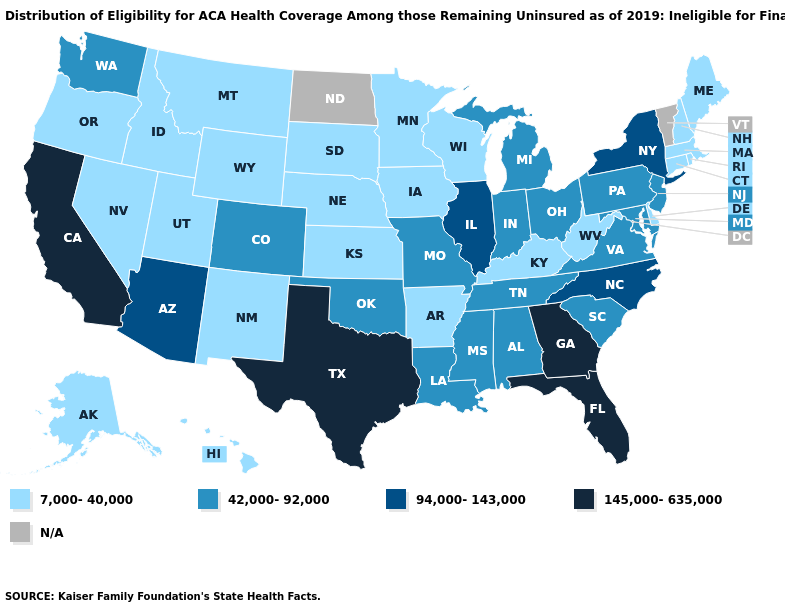What is the highest value in the USA?
Answer briefly. 145,000-635,000. What is the highest value in the USA?
Write a very short answer. 145,000-635,000. Name the states that have a value in the range 94,000-143,000?
Keep it brief. Arizona, Illinois, New York, North Carolina. Name the states that have a value in the range N/A?
Answer briefly. North Dakota, Vermont. Does the first symbol in the legend represent the smallest category?
Write a very short answer. Yes. Does the map have missing data?
Short answer required. Yes. What is the value of Oklahoma?
Short answer required. 42,000-92,000. Among the states that border West Virginia , does Maryland have the lowest value?
Be succinct. No. What is the value of Kansas?
Short answer required. 7,000-40,000. What is the value of Missouri?
Write a very short answer. 42,000-92,000. What is the lowest value in the USA?
Short answer required. 7,000-40,000. Name the states that have a value in the range 94,000-143,000?
Answer briefly. Arizona, Illinois, New York, North Carolina. Does Florida have the highest value in the USA?
Quick response, please. Yes. Name the states that have a value in the range N/A?
Answer briefly. North Dakota, Vermont. What is the highest value in states that border Texas?
Keep it brief. 42,000-92,000. 